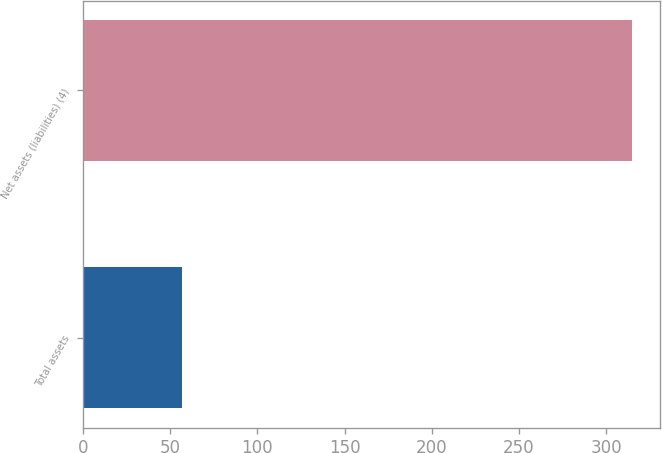Convert chart to OTSL. <chart><loc_0><loc_0><loc_500><loc_500><bar_chart><fcel>Total assets<fcel>Net assets (liabilities) (4)<nl><fcel>57<fcel>315<nl></chart> 